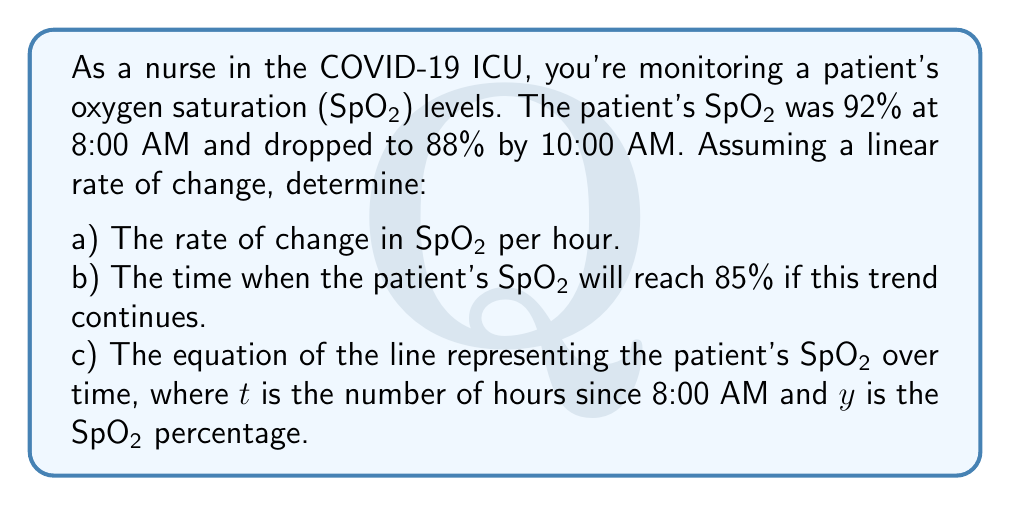Provide a solution to this math problem. Let's approach this step-by-step:

1) First, let's identify our known values:
   - Initial SpO2: 92% at 8:00 AM (t = 0)
   - Later SpO2: 88% at 10:00 AM (t = 2 hours)

2) To find the rate of change per hour:
   $$\text{Rate} = \frac{\text{Change in SpO2}}{\text{Change in time}} = \frac{88 - 92}{2 - 0} = \frac{-4}{2} = -2\% \text{ per hour}$$

3) To find when SpO2 will reach 85%, we can set up a linear equation:
   $$y = mx + b$$
   Where $m$ is our rate of change (-2), and $b$ is our initial value (92)
   $$y = -2t + 92$$

   Now, we want to find $t$ when $y = 85$:
   $$85 = -2t + 92$$
   $$-7 = -2t$$
   $$t = 3.5 \text{ hours}$$

   3.5 hours after 8:00 AM is 11:30 AM.

4) The equation of the line is already determined in step 3:
   $$y = -2t + 92$$
   Where $t$ is hours since 8:00 AM and $y$ is SpO2 percentage.
Answer: a) $-2\%$ per hour
b) 11:30 AM
c) $y = -2t + 92$ 